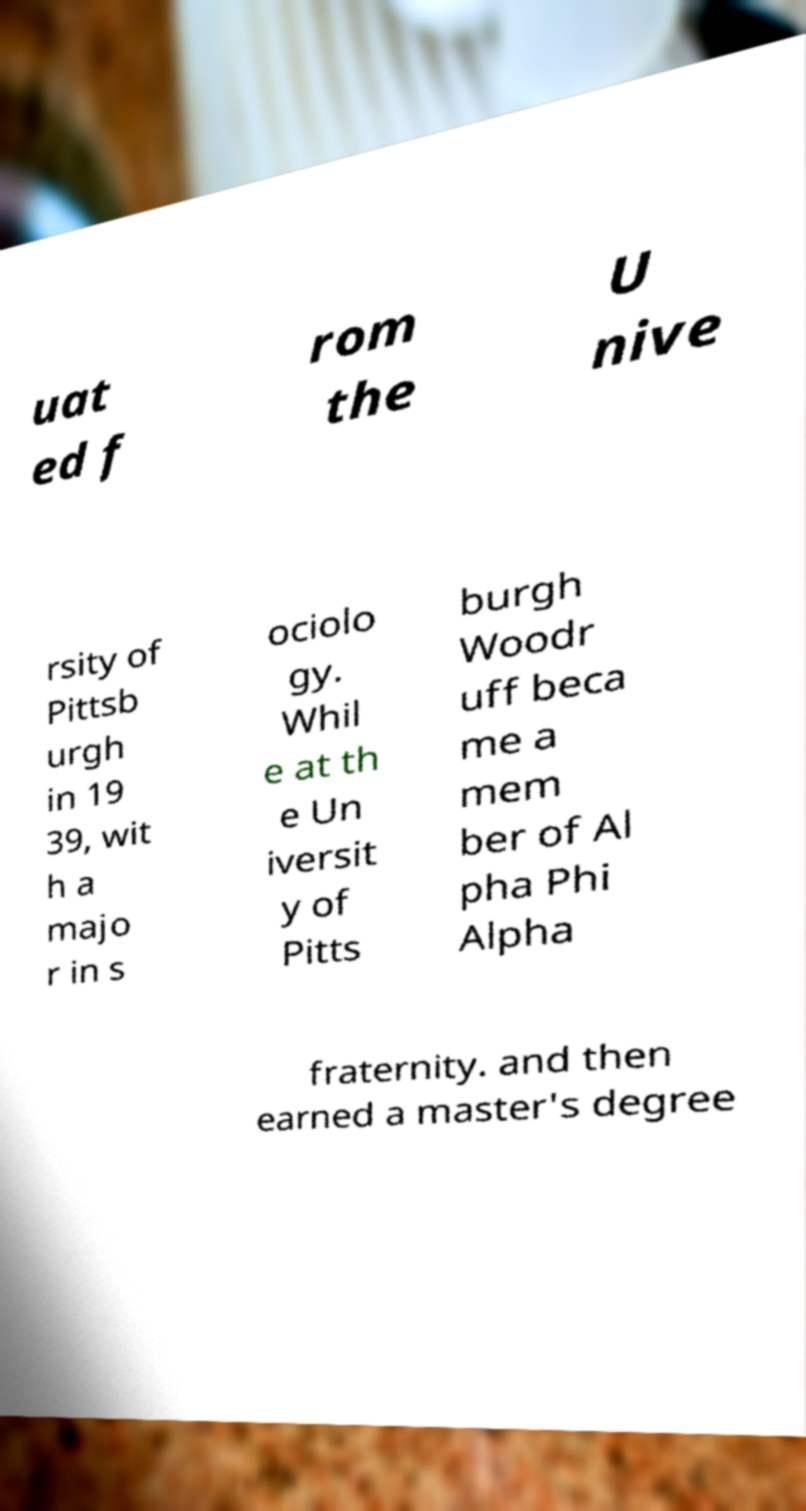Can you read and provide the text displayed in the image?This photo seems to have some interesting text. Can you extract and type it out for me? uat ed f rom the U nive rsity of Pittsb urgh in 19 39, wit h a majo r in s ociolo gy. Whil e at th e Un iversit y of Pitts burgh Woodr uff beca me a mem ber of Al pha Phi Alpha fraternity. and then earned a master's degree 